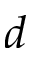Convert formula to latex. <formula><loc_0><loc_0><loc_500><loc_500>d</formula> 